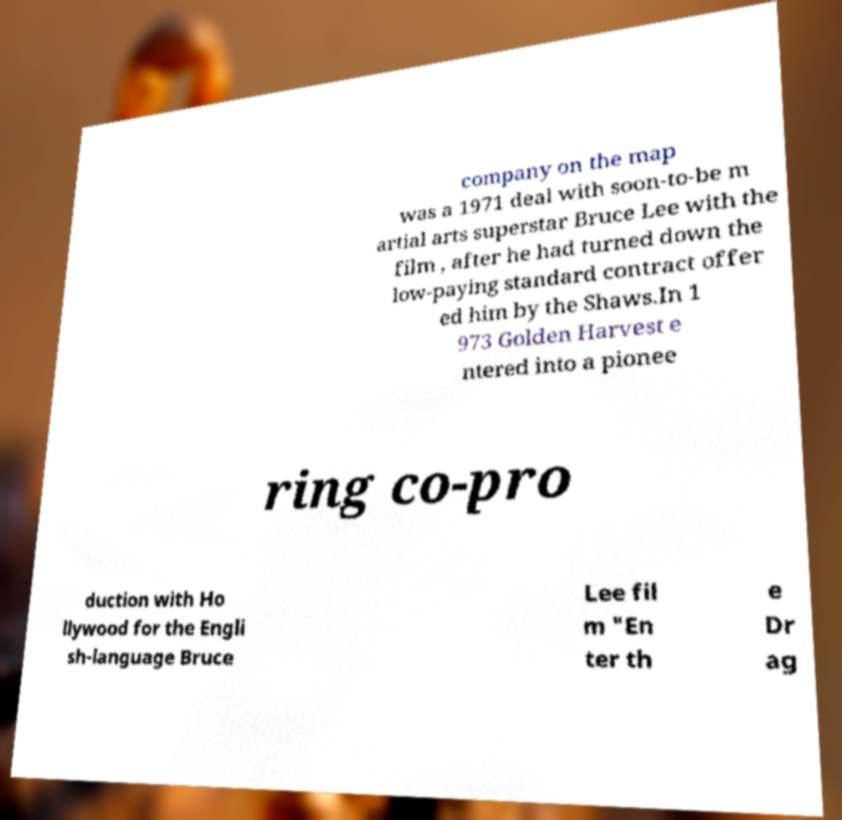I need the written content from this picture converted into text. Can you do that? company on the map was a 1971 deal with soon-to-be m artial arts superstar Bruce Lee with the film , after he had turned down the low-paying standard contract offer ed him by the Shaws.In 1 973 Golden Harvest e ntered into a pionee ring co-pro duction with Ho llywood for the Engli sh-language Bruce Lee fil m "En ter th e Dr ag 